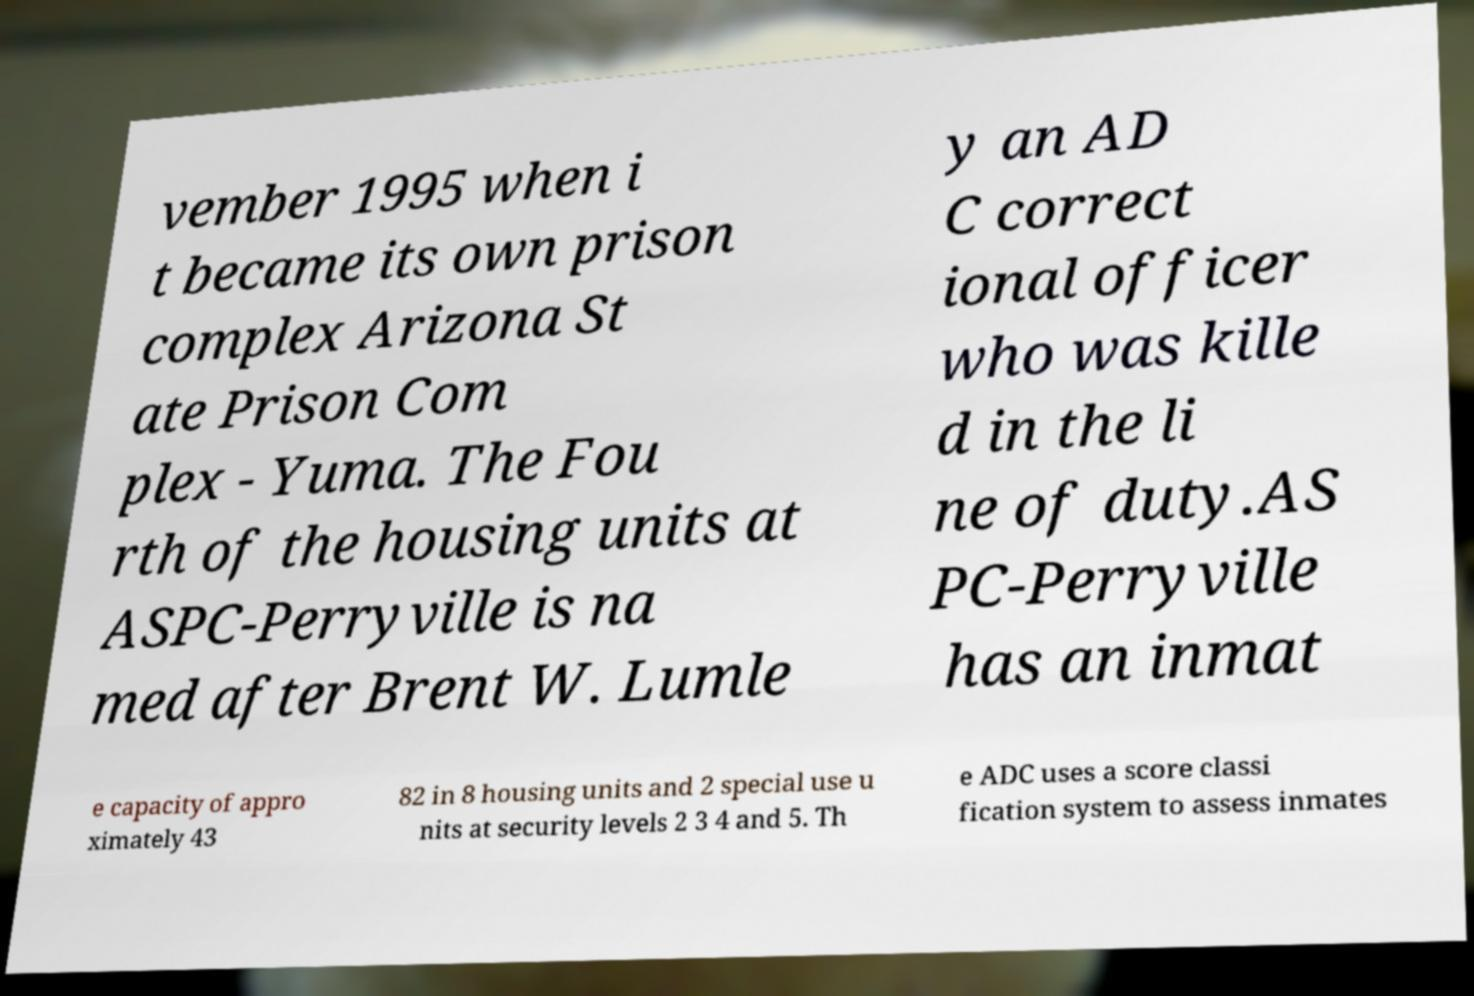There's text embedded in this image that I need extracted. Can you transcribe it verbatim? vember 1995 when i t became its own prison complex Arizona St ate Prison Com plex - Yuma. The Fou rth of the housing units at ASPC-Perryville is na med after Brent W. Lumle y an AD C correct ional officer who was kille d in the li ne of duty.AS PC-Perryville has an inmat e capacity of appro ximately 43 82 in 8 housing units and 2 special use u nits at security levels 2 3 4 and 5. Th e ADC uses a score classi fication system to assess inmates 